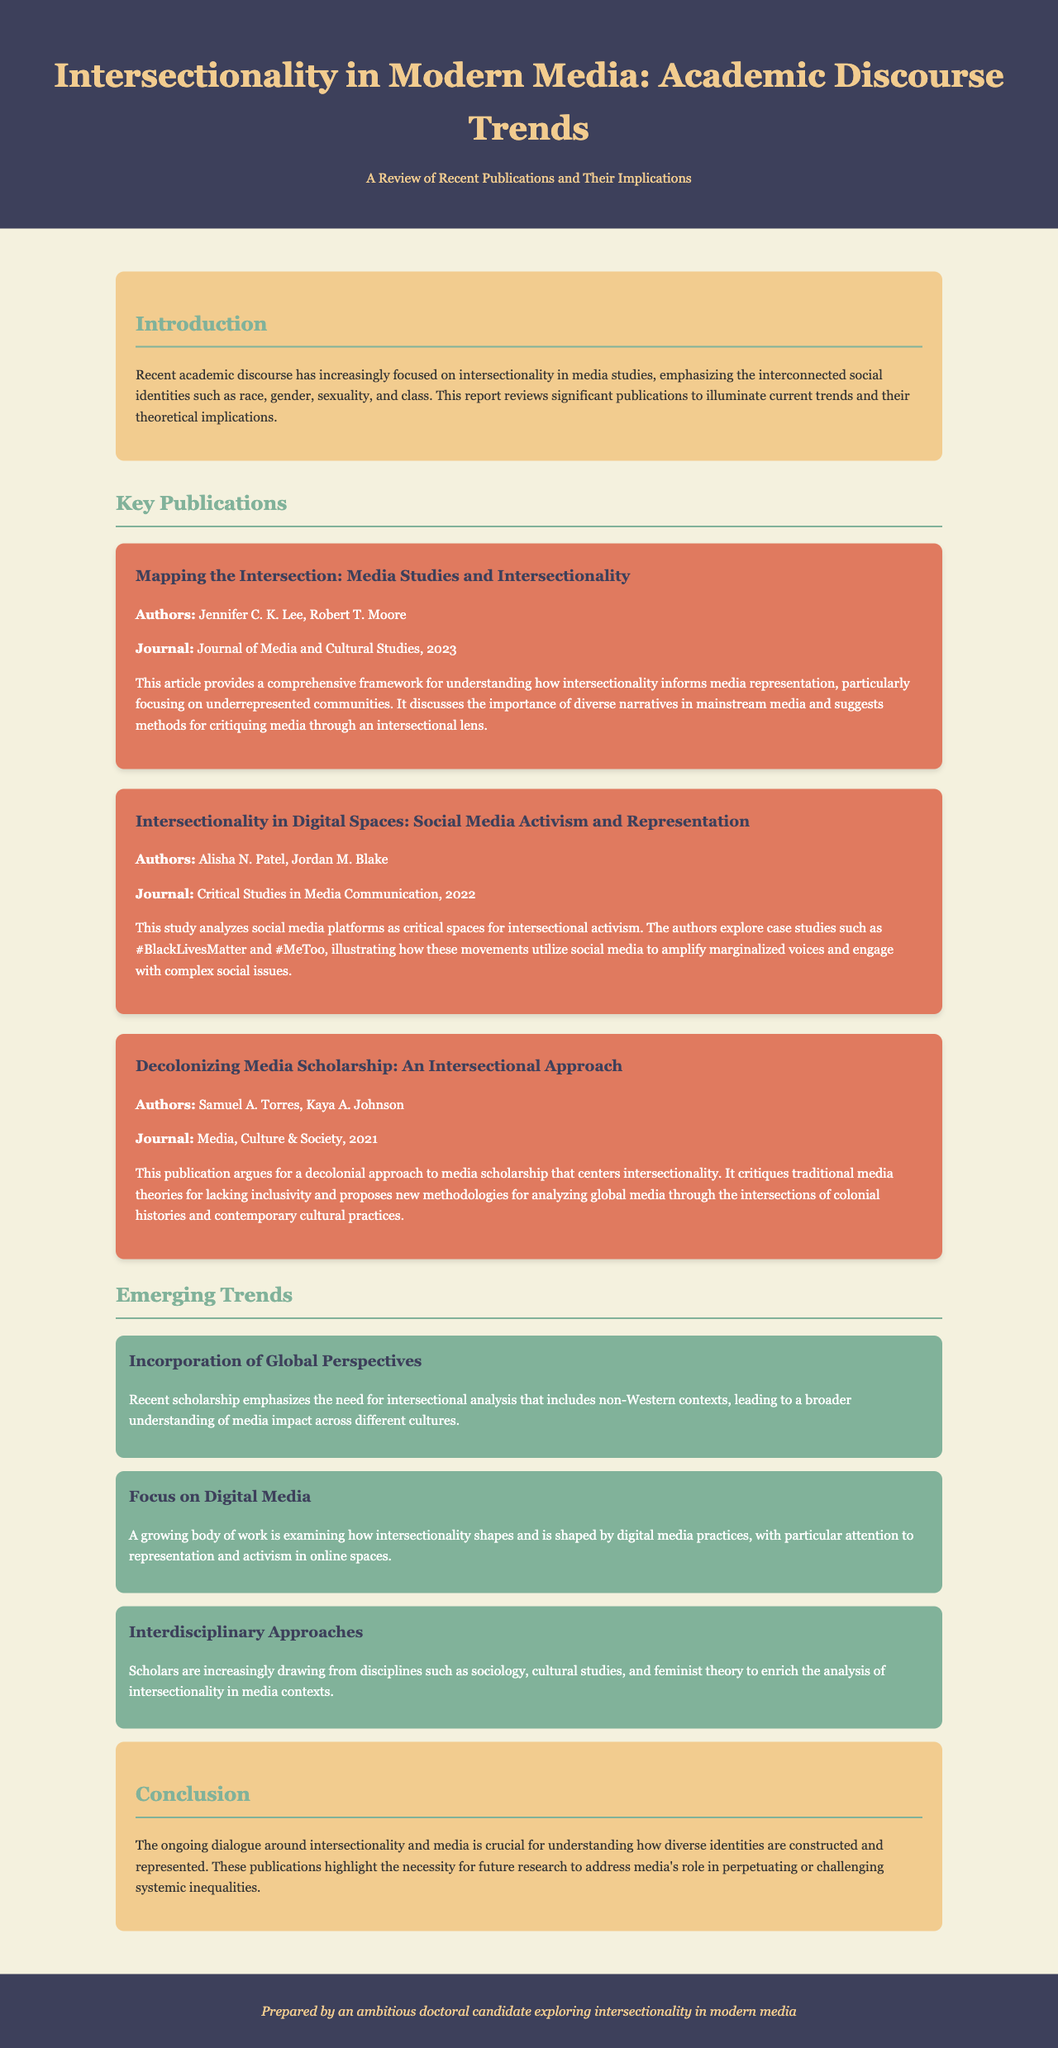What is the title of the report? The title of the report is indicated prominently in the header section of the document.
Answer: Intersectionality in Modern Media: Academic Discourse Trends Who authored the publication "Mapping the Intersection: Media Studies and Intersectionality"? The authors of this publication are listed within the relevant section of the document.
Answer: Jennifer C. K. Lee, Robert T. Moore In what year was "Intersectionality in Digital Spaces: Social Media Activism and Representation" published? The year of publication is mentioned alongside the journal name in the key publications section.
Answer: 2022 What is one of the emerging trends mentioned in the document? The document outlines several emerging trends in the trends section.
Answer: Incorporation of Global Perspectives Which journal published the article "Decolonizing Media Scholarship: An Intersectional Approach"? The journal name is specified for each publication in the key publications section of the report.
Answer: Media, Culture & Society What is the focus of the publication by Alisha N. Patel and Jordan M. Blake? The focus is described in the summary provided for their publication.
Answer: Social media platforms as critical spaces for intersectional activism How many key publications are listed in the report? The total number of key publications is given in the relevant section.
Answer: Three What is the main argument of the report's conclusion? The conclusion summarizes the ongoing dialogue and its importance in understanding diverse identities in media.
Answer: Future research to address media's role in perpetuating or challenging systemic inequalities 